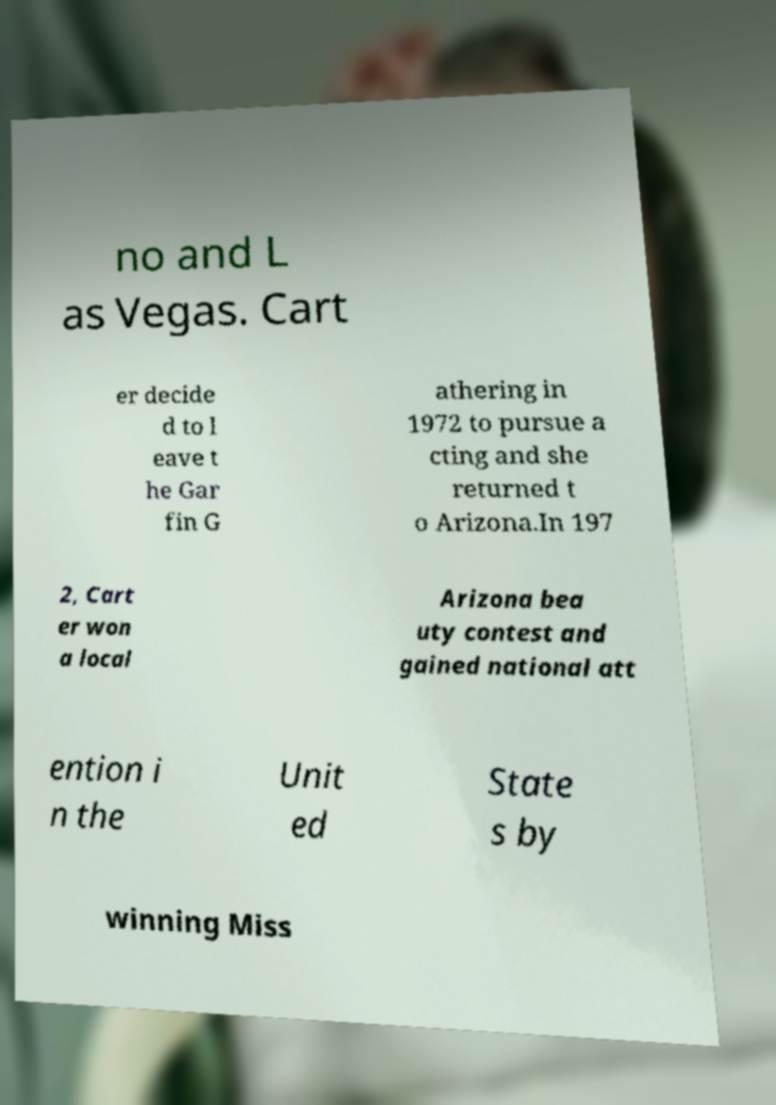I need the written content from this picture converted into text. Can you do that? no and L as Vegas. Cart er decide d to l eave t he Gar fin G athering in 1972 to pursue a cting and she returned t o Arizona.In 197 2, Cart er won a local Arizona bea uty contest and gained national att ention i n the Unit ed State s by winning Miss 